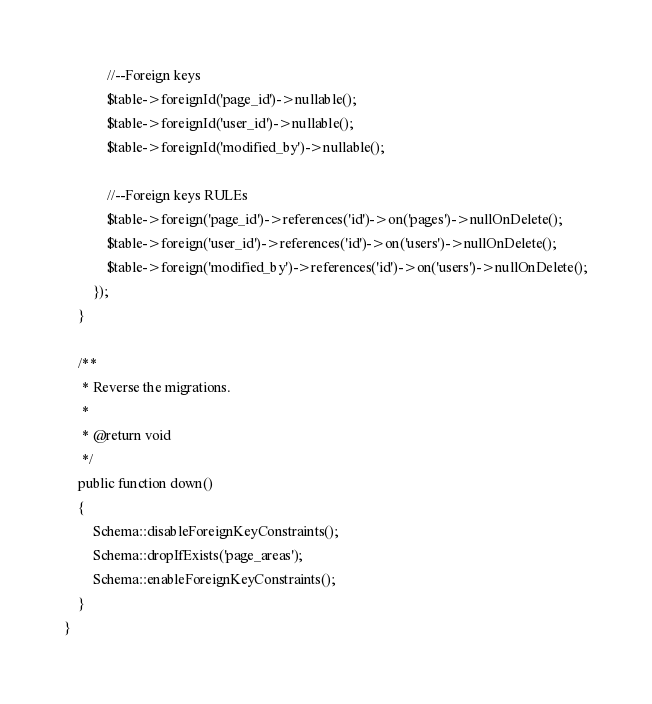<code> <loc_0><loc_0><loc_500><loc_500><_PHP_>
            //--Foreign keys
            $table->foreignId('page_id')->nullable();
            $table->foreignId('user_id')->nullable();
            $table->foreignId('modified_by')->nullable();

            //--Foreign keys RULEs
            $table->foreign('page_id')->references('id')->on('pages')->nullOnDelete();
            $table->foreign('user_id')->references('id')->on('users')->nullOnDelete();
            $table->foreign('modified_by')->references('id')->on('users')->nullOnDelete();
        });
    }

    /**
     * Reverse the migrations.
     *
     * @return void
     */
    public function down()
    {
        Schema::disableForeignKeyConstraints();
        Schema::dropIfExists('page_areas');
        Schema::enableForeignKeyConstraints();
    }
}
</code> 